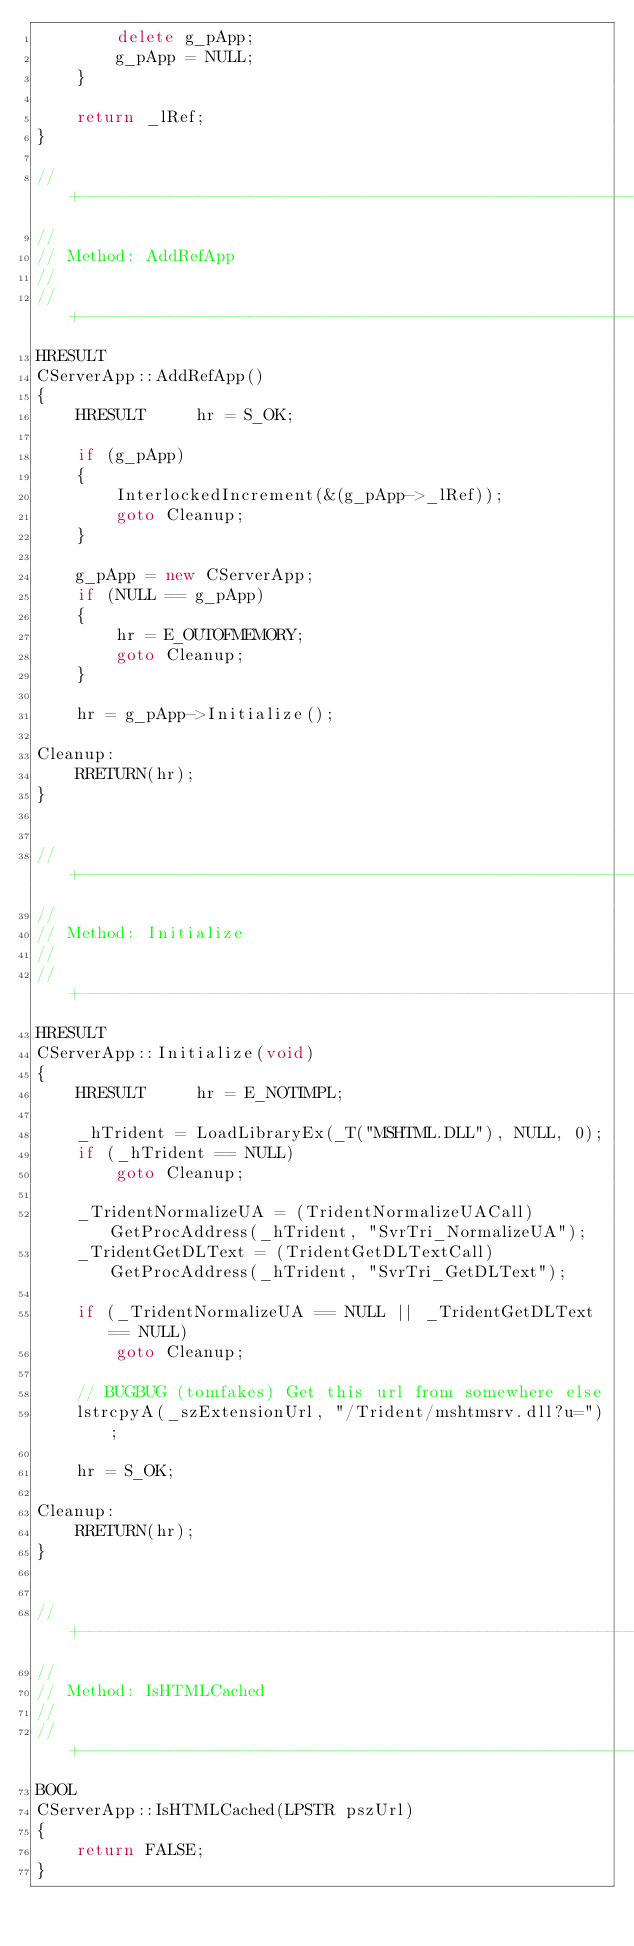<code> <loc_0><loc_0><loc_500><loc_500><_C++_>        delete g_pApp;
        g_pApp = NULL;
    }

    return _lRef;
}

//+----------------------------------------------------------------------------
//
// Method: AddRefApp
//
//+----------------------------------------------------------------------------
HRESULT
CServerApp::AddRefApp()
{
    HRESULT     hr = S_OK;

    if (g_pApp)
    {
        InterlockedIncrement(&(g_pApp->_lRef));
        goto Cleanup;
    }

    g_pApp = new CServerApp;
    if (NULL == g_pApp)
    {
        hr = E_OUTOFMEMORY;
        goto Cleanup;
    }

    hr = g_pApp->Initialize();

Cleanup:
    RRETURN(hr);
}


//+----------------------------------------------------------------------------
//
// Method: Initialize
//
//+----------------------------------------------------------------------------
HRESULT
CServerApp::Initialize(void)
{
    HRESULT     hr = E_NOTIMPL;

    _hTrident = LoadLibraryEx(_T("MSHTML.DLL"), NULL, 0);
    if (_hTrident == NULL) 
        goto Cleanup;

    _TridentNormalizeUA = (TridentNormalizeUACall)GetProcAddress(_hTrident, "SvrTri_NormalizeUA");
    _TridentGetDLText = (TridentGetDLTextCall)GetProcAddress(_hTrident, "SvrTri_GetDLText");

    if (_TridentNormalizeUA == NULL || _TridentGetDLText == NULL) 
        goto Cleanup;

    // BUGBUG (tomfakes) Get this url from somewhere else
    lstrcpyA(_szExtensionUrl, "/Trident/mshtmsrv.dll?u=");

    hr = S_OK;

Cleanup:
    RRETURN(hr);
}


//+----------------------------------------------------------------------------
//
// Method: IsHTMLCached
//
//+----------------------------------------------------------------------------
BOOL
CServerApp::IsHTMLCached(LPSTR pszUrl)
{
    return FALSE;
}
</code> 